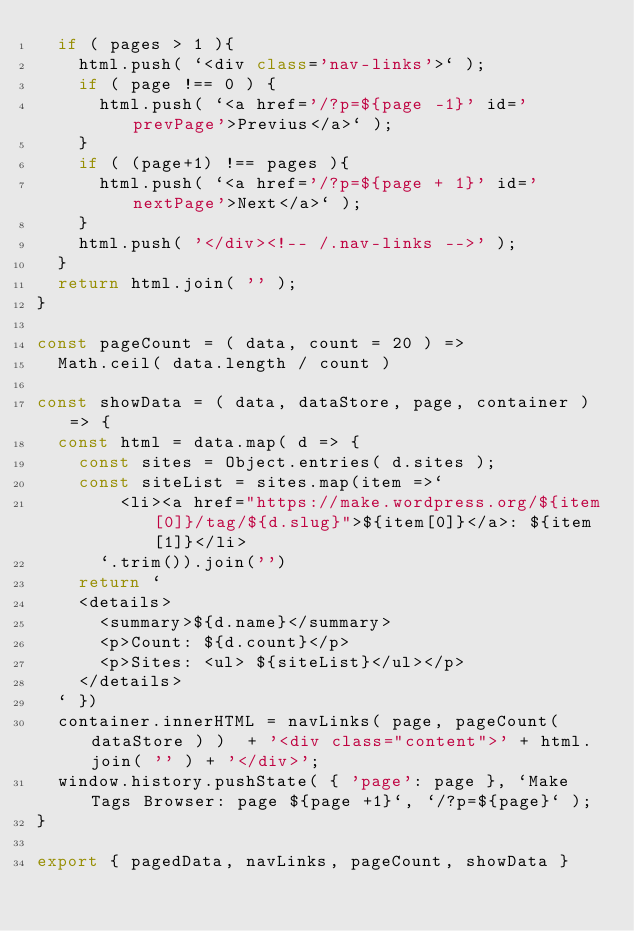<code> <loc_0><loc_0><loc_500><loc_500><_JavaScript_>	if ( pages > 1 ){
		html.push( `<div class='nav-links'>` );
		if ( page !== 0 ) {
			html.push( `<a href='/?p=${page -1}' id='prevPage'>Previus</a>` );
		}
		if ( (page+1) !== pages ){
			html.push( `<a href='/?p=${page + 1}' id='nextPage'>Next</a>` );
		}
		html.push( '</div><!-- /.nav-links -->' );
	}
	return html.join( '' );
}

const pageCount = ( data, count = 20 ) =>
	Math.ceil( data.length / count )	

const showData = ( data, dataStore, page, container ) => {	
	const html = data.map( d => {
		const sites = Object.entries( d.sites );	
		const siteList = sites.map(item =>`
				<li><a href="https://make.wordpress.org/${item[0]}/tag/${d.slug}">${item[0]}</a>: ${item[1]}</li>
			`.trim()).join('')
		return `
		<details>
			<summary>${d.name}</summary>
			<p>Count: ${d.count}</p>
			<p>Sites: <ul> ${siteList}</ul></p>
		</details>
	` }) 
	container.innerHTML = navLinks( page, pageCount( dataStore ) )  + '<div class="content">' + html.join( '' ) + '</div>';
	window.history.pushState( { 'page': page }, `Make Tags Browser: page ${page +1}`, `/?p=${page}` );
}

export { pagedData, navLinks, pageCount, showData }
</code> 